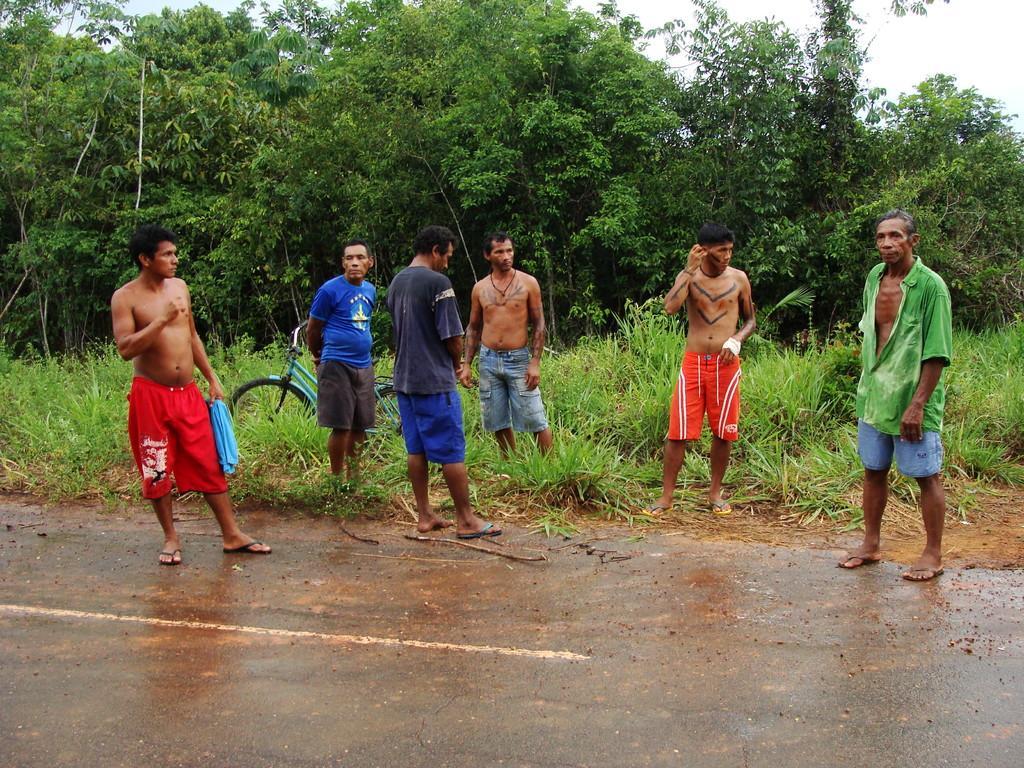In one or two sentences, can you explain what this image depicts? In this image there are group of persons standing. In the background there is grass on the ground. There is a bicycle and there are trees. 